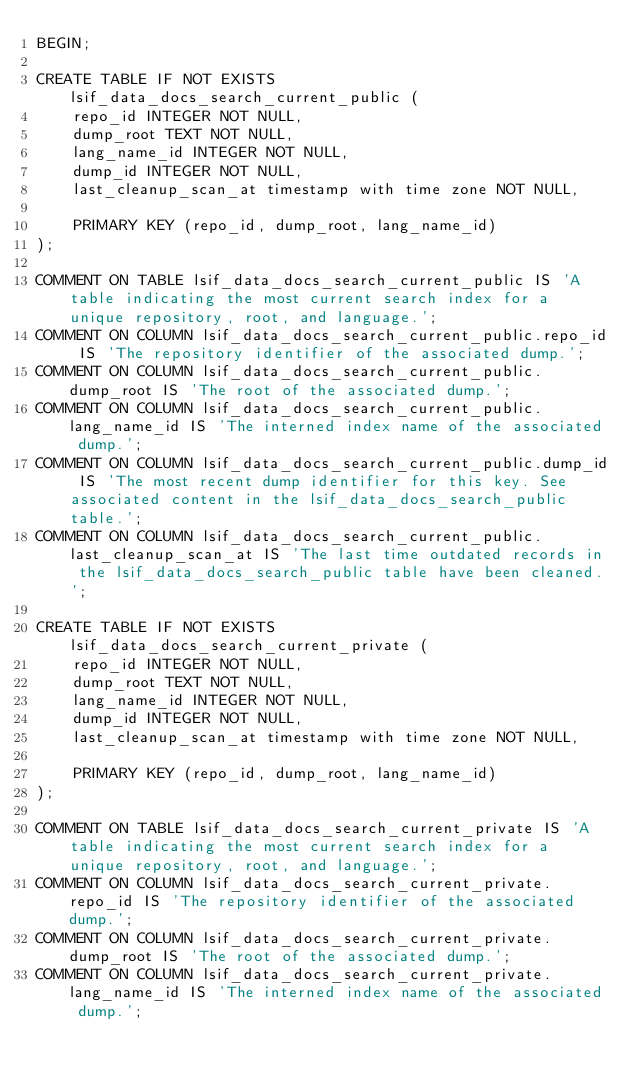Convert code to text. <code><loc_0><loc_0><loc_500><loc_500><_SQL_>BEGIN;

CREATE TABLE IF NOT EXISTS lsif_data_docs_search_current_public (
    repo_id INTEGER NOT NULL,
    dump_root TEXT NOT NULL,
    lang_name_id INTEGER NOT NULL,
    dump_id INTEGER NOT NULL,
    last_cleanup_scan_at timestamp with time zone NOT NULL,

    PRIMARY KEY (repo_id, dump_root, lang_name_id)
);

COMMENT ON TABLE lsif_data_docs_search_current_public IS 'A table indicating the most current search index for a unique repository, root, and language.';
COMMENT ON COLUMN lsif_data_docs_search_current_public.repo_id IS 'The repository identifier of the associated dump.';
COMMENT ON COLUMN lsif_data_docs_search_current_public.dump_root IS 'The root of the associated dump.';
COMMENT ON COLUMN lsif_data_docs_search_current_public.lang_name_id IS 'The interned index name of the associated dump.';
COMMENT ON COLUMN lsif_data_docs_search_current_public.dump_id IS 'The most recent dump identifier for this key. See associated content in the lsif_data_docs_search_public table.';
COMMENT ON COLUMN lsif_data_docs_search_current_public.last_cleanup_scan_at IS 'The last time outdated records in the lsif_data_docs_search_public table have been cleaned.';

CREATE TABLE IF NOT EXISTS lsif_data_docs_search_current_private (
    repo_id INTEGER NOT NULL,
    dump_root TEXT NOT NULL,
    lang_name_id INTEGER NOT NULL,
    dump_id INTEGER NOT NULL,
    last_cleanup_scan_at timestamp with time zone NOT NULL,

    PRIMARY KEY (repo_id, dump_root, lang_name_id)
);

COMMENT ON TABLE lsif_data_docs_search_current_private IS 'A table indicating the most current search index for a unique repository, root, and language.';
COMMENT ON COLUMN lsif_data_docs_search_current_private.repo_id IS 'The repository identifier of the associated dump.';
COMMENT ON COLUMN lsif_data_docs_search_current_private.dump_root IS 'The root of the associated dump.';
COMMENT ON COLUMN lsif_data_docs_search_current_private.lang_name_id IS 'The interned index name of the associated dump.';</code> 